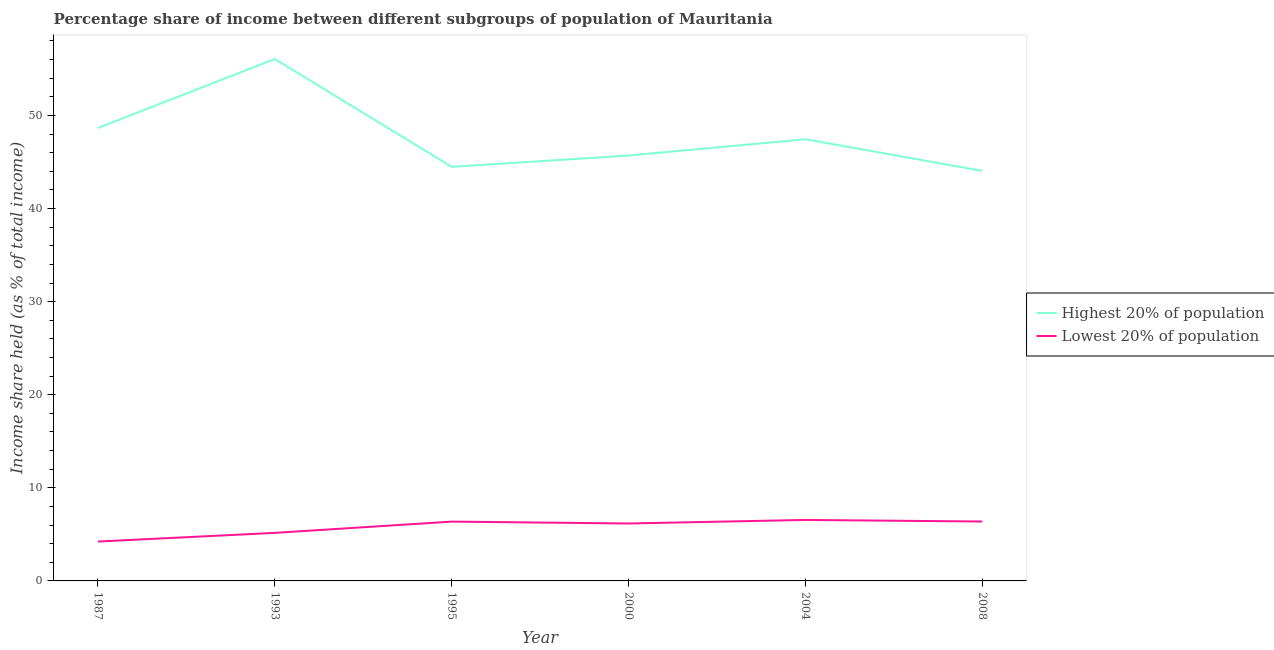How many different coloured lines are there?
Give a very brief answer. 2. What is the income share held by lowest 20% of the population in 2008?
Your answer should be very brief. 6.38. Across all years, what is the maximum income share held by lowest 20% of the population?
Your answer should be very brief. 6.55. Across all years, what is the minimum income share held by lowest 20% of the population?
Your answer should be compact. 4.23. What is the total income share held by lowest 20% of the population in the graph?
Provide a short and direct response. 34.86. What is the difference between the income share held by lowest 20% of the population in 1987 and that in 1993?
Offer a terse response. -0.93. What is the difference between the income share held by lowest 20% of the population in 2004 and the income share held by highest 20% of the population in 2000?
Offer a terse response. -39.14. What is the average income share held by highest 20% of the population per year?
Provide a short and direct response. 47.73. In the year 2000, what is the difference between the income share held by lowest 20% of the population and income share held by highest 20% of the population?
Give a very brief answer. -39.52. In how many years, is the income share held by lowest 20% of the population greater than 20 %?
Make the answer very short. 0. What is the ratio of the income share held by lowest 20% of the population in 1993 to that in 2004?
Ensure brevity in your answer.  0.79. Is the income share held by lowest 20% of the population in 1993 less than that in 2008?
Offer a very short reply. Yes. Is the difference between the income share held by highest 20% of the population in 2000 and 2004 greater than the difference between the income share held by lowest 20% of the population in 2000 and 2004?
Provide a short and direct response. No. What is the difference between the highest and the second highest income share held by lowest 20% of the population?
Make the answer very short. 0.17. What is the difference between the highest and the lowest income share held by highest 20% of the population?
Your answer should be very brief. 12.02. Is the sum of the income share held by highest 20% of the population in 1987 and 2008 greater than the maximum income share held by lowest 20% of the population across all years?
Ensure brevity in your answer.  Yes. Does the income share held by highest 20% of the population monotonically increase over the years?
Give a very brief answer. No. How many lines are there?
Make the answer very short. 2. How many years are there in the graph?
Keep it short and to the point. 6. What is the difference between two consecutive major ticks on the Y-axis?
Offer a terse response. 10. Are the values on the major ticks of Y-axis written in scientific E-notation?
Offer a terse response. No. Does the graph contain any zero values?
Provide a succinct answer. No. What is the title of the graph?
Provide a short and direct response. Percentage share of income between different subgroups of population of Mauritania. What is the label or title of the X-axis?
Ensure brevity in your answer.  Year. What is the label or title of the Y-axis?
Your answer should be compact. Income share held (as % of total income). What is the Income share held (as % of total income) of Highest 20% of population in 1987?
Give a very brief answer. 48.65. What is the Income share held (as % of total income) of Lowest 20% of population in 1987?
Make the answer very short. 4.23. What is the Income share held (as % of total income) of Highest 20% of population in 1993?
Provide a short and direct response. 56.06. What is the Income share held (as % of total income) in Lowest 20% of population in 1993?
Offer a very short reply. 5.16. What is the Income share held (as % of total income) of Highest 20% of population in 1995?
Offer a very short reply. 44.48. What is the Income share held (as % of total income) of Lowest 20% of population in 1995?
Give a very brief answer. 6.37. What is the Income share held (as % of total income) in Highest 20% of population in 2000?
Ensure brevity in your answer.  45.69. What is the Income share held (as % of total income) of Lowest 20% of population in 2000?
Your answer should be very brief. 6.17. What is the Income share held (as % of total income) of Highest 20% of population in 2004?
Provide a succinct answer. 47.44. What is the Income share held (as % of total income) of Lowest 20% of population in 2004?
Your answer should be compact. 6.55. What is the Income share held (as % of total income) of Highest 20% of population in 2008?
Provide a succinct answer. 44.04. What is the Income share held (as % of total income) of Lowest 20% of population in 2008?
Keep it short and to the point. 6.38. Across all years, what is the maximum Income share held (as % of total income) in Highest 20% of population?
Your response must be concise. 56.06. Across all years, what is the maximum Income share held (as % of total income) of Lowest 20% of population?
Offer a very short reply. 6.55. Across all years, what is the minimum Income share held (as % of total income) of Highest 20% of population?
Provide a short and direct response. 44.04. Across all years, what is the minimum Income share held (as % of total income) of Lowest 20% of population?
Ensure brevity in your answer.  4.23. What is the total Income share held (as % of total income) of Highest 20% of population in the graph?
Keep it short and to the point. 286.36. What is the total Income share held (as % of total income) in Lowest 20% of population in the graph?
Give a very brief answer. 34.86. What is the difference between the Income share held (as % of total income) in Highest 20% of population in 1987 and that in 1993?
Offer a very short reply. -7.41. What is the difference between the Income share held (as % of total income) in Lowest 20% of population in 1987 and that in 1993?
Your response must be concise. -0.93. What is the difference between the Income share held (as % of total income) of Highest 20% of population in 1987 and that in 1995?
Offer a very short reply. 4.17. What is the difference between the Income share held (as % of total income) in Lowest 20% of population in 1987 and that in 1995?
Provide a short and direct response. -2.14. What is the difference between the Income share held (as % of total income) in Highest 20% of population in 1987 and that in 2000?
Give a very brief answer. 2.96. What is the difference between the Income share held (as % of total income) in Lowest 20% of population in 1987 and that in 2000?
Offer a very short reply. -1.94. What is the difference between the Income share held (as % of total income) of Highest 20% of population in 1987 and that in 2004?
Offer a very short reply. 1.21. What is the difference between the Income share held (as % of total income) of Lowest 20% of population in 1987 and that in 2004?
Make the answer very short. -2.32. What is the difference between the Income share held (as % of total income) in Highest 20% of population in 1987 and that in 2008?
Offer a terse response. 4.61. What is the difference between the Income share held (as % of total income) in Lowest 20% of population in 1987 and that in 2008?
Your answer should be compact. -2.15. What is the difference between the Income share held (as % of total income) of Highest 20% of population in 1993 and that in 1995?
Your response must be concise. 11.58. What is the difference between the Income share held (as % of total income) in Lowest 20% of population in 1993 and that in 1995?
Ensure brevity in your answer.  -1.21. What is the difference between the Income share held (as % of total income) of Highest 20% of population in 1993 and that in 2000?
Keep it short and to the point. 10.37. What is the difference between the Income share held (as % of total income) of Lowest 20% of population in 1993 and that in 2000?
Offer a very short reply. -1.01. What is the difference between the Income share held (as % of total income) of Highest 20% of population in 1993 and that in 2004?
Provide a succinct answer. 8.62. What is the difference between the Income share held (as % of total income) of Lowest 20% of population in 1993 and that in 2004?
Your answer should be compact. -1.39. What is the difference between the Income share held (as % of total income) in Highest 20% of population in 1993 and that in 2008?
Ensure brevity in your answer.  12.02. What is the difference between the Income share held (as % of total income) of Lowest 20% of population in 1993 and that in 2008?
Your answer should be very brief. -1.22. What is the difference between the Income share held (as % of total income) in Highest 20% of population in 1995 and that in 2000?
Provide a short and direct response. -1.21. What is the difference between the Income share held (as % of total income) of Highest 20% of population in 1995 and that in 2004?
Ensure brevity in your answer.  -2.96. What is the difference between the Income share held (as % of total income) of Lowest 20% of population in 1995 and that in 2004?
Your answer should be very brief. -0.18. What is the difference between the Income share held (as % of total income) in Highest 20% of population in 1995 and that in 2008?
Give a very brief answer. 0.44. What is the difference between the Income share held (as % of total income) of Lowest 20% of population in 1995 and that in 2008?
Give a very brief answer. -0.01. What is the difference between the Income share held (as % of total income) of Highest 20% of population in 2000 and that in 2004?
Make the answer very short. -1.75. What is the difference between the Income share held (as % of total income) in Lowest 20% of population in 2000 and that in 2004?
Make the answer very short. -0.38. What is the difference between the Income share held (as % of total income) of Highest 20% of population in 2000 and that in 2008?
Offer a terse response. 1.65. What is the difference between the Income share held (as % of total income) of Lowest 20% of population in 2000 and that in 2008?
Give a very brief answer. -0.21. What is the difference between the Income share held (as % of total income) in Highest 20% of population in 2004 and that in 2008?
Your response must be concise. 3.4. What is the difference between the Income share held (as % of total income) of Lowest 20% of population in 2004 and that in 2008?
Make the answer very short. 0.17. What is the difference between the Income share held (as % of total income) in Highest 20% of population in 1987 and the Income share held (as % of total income) in Lowest 20% of population in 1993?
Ensure brevity in your answer.  43.49. What is the difference between the Income share held (as % of total income) of Highest 20% of population in 1987 and the Income share held (as % of total income) of Lowest 20% of population in 1995?
Give a very brief answer. 42.28. What is the difference between the Income share held (as % of total income) of Highest 20% of population in 1987 and the Income share held (as % of total income) of Lowest 20% of population in 2000?
Offer a terse response. 42.48. What is the difference between the Income share held (as % of total income) in Highest 20% of population in 1987 and the Income share held (as % of total income) in Lowest 20% of population in 2004?
Provide a short and direct response. 42.1. What is the difference between the Income share held (as % of total income) in Highest 20% of population in 1987 and the Income share held (as % of total income) in Lowest 20% of population in 2008?
Make the answer very short. 42.27. What is the difference between the Income share held (as % of total income) in Highest 20% of population in 1993 and the Income share held (as % of total income) in Lowest 20% of population in 1995?
Ensure brevity in your answer.  49.69. What is the difference between the Income share held (as % of total income) in Highest 20% of population in 1993 and the Income share held (as % of total income) in Lowest 20% of population in 2000?
Offer a very short reply. 49.89. What is the difference between the Income share held (as % of total income) in Highest 20% of population in 1993 and the Income share held (as % of total income) in Lowest 20% of population in 2004?
Offer a terse response. 49.51. What is the difference between the Income share held (as % of total income) of Highest 20% of population in 1993 and the Income share held (as % of total income) of Lowest 20% of population in 2008?
Give a very brief answer. 49.68. What is the difference between the Income share held (as % of total income) in Highest 20% of population in 1995 and the Income share held (as % of total income) in Lowest 20% of population in 2000?
Keep it short and to the point. 38.31. What is the difference between the Income share held (as % of total income) in Highest 20% of population in 1995 and the Income share held (as % of total income) in Lowest 20% of population in 2004?
Provide a succinct answer. 37.93. What is the difference between the Income share held (as % of total income) of Highest 20% of population in 1995 and the Income share held (as % of total income) of Lowest 20% of population in 2008?
Offer a very short reply. 38.1. What is the difference between the Income share held (as % of total income) in Highest 20% of population in 2000 and the Income share held (as % of total income) in Lowest 20% of population in 2004?
Provide a succinct answer. 39.14. What is the difference between the Income share held (as % of total income) in Highest 20% of population in 2000 and the Income share held (as % of total income) in Lowest 20% of population in 2008?
Make the answer very short. 39.31. What is the difference between the Income share held (as % of total income) of Highest 20% of population in 2004 and the Income share held (as % of total income) of Lowest 20% of population in 2008?
Offer a terse response. 41.06. What is the average Income share held (as % of total income) of Highest 20% of population per year?
Provide a succinct answer. 47.73. What is the average Income share held (as % of total income) in Lowest 20% of population per year?
Ensure brevity in your answer.  5.81. In the year 1987, what is the difference between the Income share held (as % of total income) of Highest 20% of population and Income share held (as % of total income) of Lowest 20% of population?
Your answer should be very brief. 44.42. In the year 1993, what is the difference between the Income share held (as % of total income) of Highest 20% of population and Income share held (as % of total income) of Lowest 20% of population?
Give a very brief answer. 50.9. In the year 1995, what is the difference between the Income share held (as % of total income) in Highest 20% of population and Income share held (as % of total income) in Lowest 20% of population?
Offer a very short reply. 38.11. In the year 2000, what is the difference between the Income share held (as % of total income) of Highest 20% of population and Income share held (as % of total income) of Lowest 20% of population?
Provide a short and direct response. 39.52. In the year 2004, what is the difference between the Income share held (as % of total income) of Highest 20% of population and Income share held (as % of total income) of Lowest 20% of population?
Make the answer very short. 40.89. In the year 2008, what is the difference between the Income share held (as % of total income) in Highest 20% of population and Income share held (as % of total income) in Lowest 20% of population?
Your response must be concise. 37.66. What is the ratio of the Income share held (as % of total income) of Highest 20% of population in 1987 to that in 1993?
Your answer should be compact. 0.87. What is the ratio of the Income share held (as % of total income) in Lowest 20% of population in 1987 to that in 1993?
Your response must be concise. 0.82. What is the ratio of the Income share held (as % of total income) of Highest 20% of population in 1987 to that in 1995?
Ensure brevity in your answer.  1.09. What is the ratio of the Income share held (as % of total income) in Lowest 20% of population in 1987 to that in 1995?
Provide a short and direct response. 0.66. What is the ratio of the Income share held (as % of total income) of Highest 20% of population in 1987 to that in 2000?
Make the answer very short. 1.06. What is the ratio of the Income share held (as % of total income) in Lowest 20% of population in 1987 to that in 2000?
Your answer should be compact. 0.69. What is the ratio of the Income share held (as % of total income) in Highest 20% of population in 1987 to that in 2004?
Provide a succinct answer. 1.03. What is the ratio of the Income share held (as % of total income) in Lowest 20% of population in 1987 to that in 2004?
Provide a succinct answer. 0.65. What is the ratio of the Income share held (as % of total income) in Highest 20% of population in 1987 to that in 2008?
Offer a terse response. 1.1. What is the ratio of the Income share held (as % of total income) in Lowest 20% of population in 1987 to that in 2008?
Make the answer very short. 0.66. What is the ratio of the Income share held (as % of total income) in Highest 20% of population in 1993 to that in 1995?
Make the answer very short. 1.26. What is the ratio of the Income share held (as % of total income) of Lowest 20% of population in 1993 to that in 1995?
Provide a succinct answer. 0.81. What is the ratio of the Income share held (as % of total income) in Highest 20% of population in 1993 to that in 2000?
Your answer should be very brief. 1.23. What is the ratio of the Income share held (as % of total income) in Lowest 20% of population in 1993 to that in 2000?
Give a very brief answer. 0.84. What is the ratio of the Income share held (as % of total income) of Highest 20% of population in 1993 to that in 2004?
Provide a succinct answer. 1.18. What is the ratio of the Income share held (as % of total income) of Lowest 20% of population in 1993 to that in 2004?
Your response must be concise. 0.79. What is the ratio of the Income share held (as % of total income) of Highest 20% of population in 1993 to that in 2008?
Your response must be concise. 1.27. What is the ratio of the Income share held (as % of total income) in Lowest 20% of population in 1993 to that in 2008?
Your answer should be compact. 0.81. What is the ratio of the Income share held (as % of total income) in Highest 20% of population in 1995 to that in 2000?
Offer a terse response. 0.97. What is the ratio of the Income share held (as % of total income) of Lowest 20% of population in 1995 to that in 2000?
Give a very brief answer. 1.03. What is the ratio of the Income share held (as % of total income) in Highest 20% of population in 1995 to that in 2004?
Offer a terse response. 0.94. What is the ratio of the Income share held (as % of total income) in Lowest 20% of population in 1995 to that in 2004?
Make the answer very short. 0.97. What is the ratio of the Income share held (as % of total income) of Highest 20% of population in 2000 to that in 2004?
Offer a terse response. 0.96. What is the ratio of the Income share held (as % of total income) in Lowest 20% of population in 2000 to that in 2004?
Ensure brevity in your answer.  0.94. What is the ratio of the Income share held (as % of total income) of Highest 20% of population in 2000 to that in 2008?
Provide a succinct answer. 1.04. What is the ratio of the Income share held (as % of total income) of Lowest 20% of population in 2000 to that in 2008?
Give a very brief answer. 0.97. What is the ratio of the Income share held (as % of total income) of Highest 20% of population in 2004 to that in 2008?
Your response must be concise. 1.08. What is the ratio of the Income share held (as % of total income) in Lowest 20% of population in 2004 to that in 2008?
Your response must be concise. 1.03. What is the difference between the highest and the second highest Income share held (as % of total income) in Highest 20% of population?
Keep it short and to the point. 7.41. What is the difference between the highest and the second highest Income share held (as % of total income) in Lowest 20% of population?
Your answer should be very brief. 0.17. What is the difference between the highest and the lowest Income share held (as % of total income) of Highest 20% of population?
Provide a short and direct response. 12.02. What is the difference between the highest and the lowest Income share held (as % of total income) in Lowest 20% of population?
Offer a terse response. 2.32. 